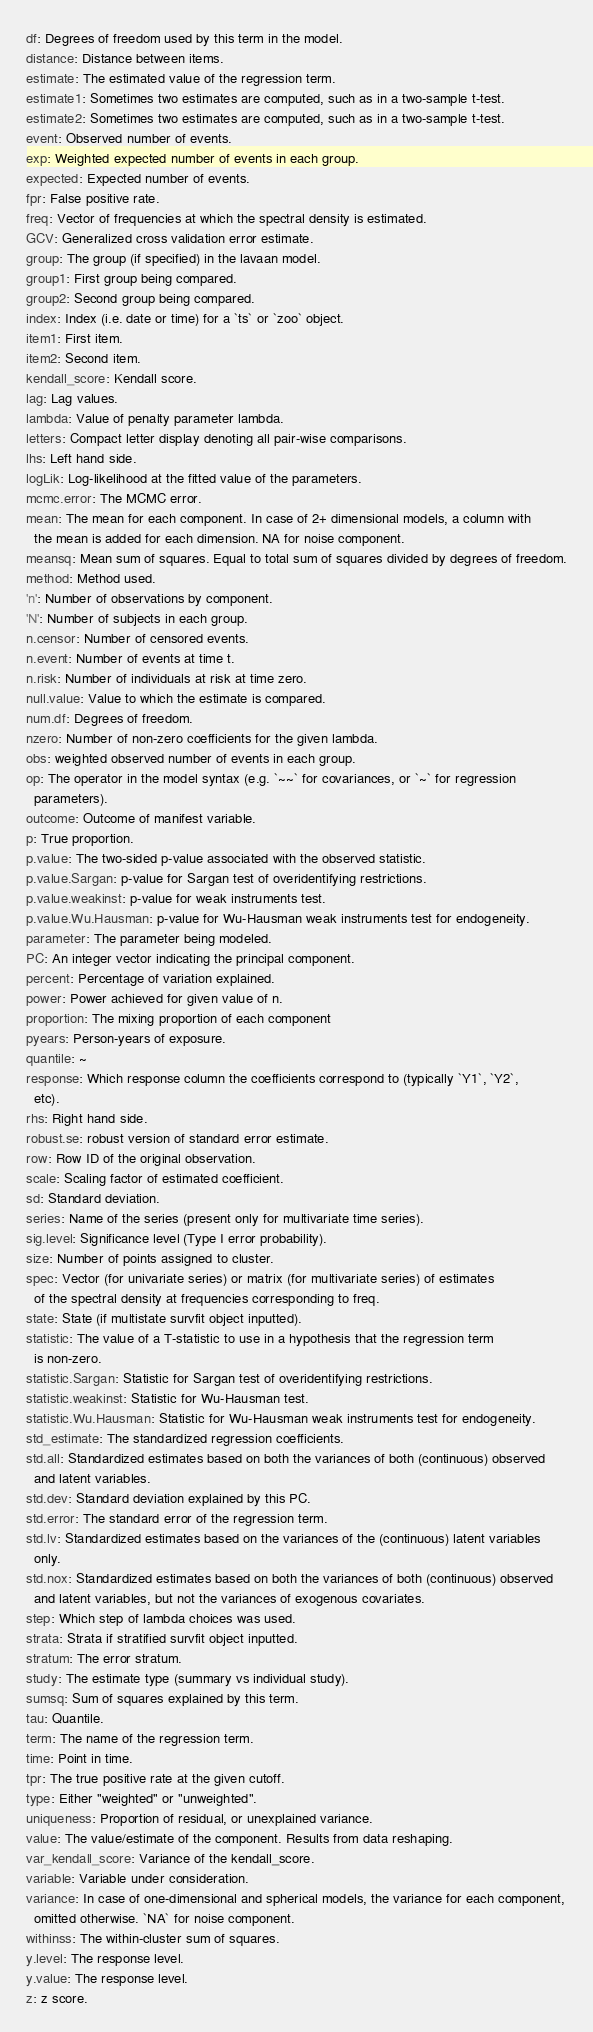Convert code to text. <code><loc_0><loc_0><loc_500><loc_500><_YAML_>df: Degrees of freedom used by this term in the model.
distance: Distance between items.
estimate: The estimated value of the regression term.
estimate1: Sometimes two estimates are computed, such as in a two-sample t-test.
estimate2: Sometimes two estimates are computed, such as in a two-sample t-test.
event: Observed number of events.
exp: Weighted expected number of events in each group.
expected: Expected number of events.
fpr: False positive rate.
freq: Vector of frequencies at which the spectral density is estimated.
GCV: Generalized cross validation error estimate.
group: The group (if specified) in the lavaan model.
group1: First group being compared.
group2: Second group being compared.
index: Index (i.e. date or time) for a `ts` or `zoo` object.
item1: First item.
item2: Second item.
kendall_score: Kendall score.
lag: Lag values.
lambda: Value of penalty parameter lambda.
letters: Compact letter display denoting all pair-wise comparisons.
lhs: Left hand side.
logLik: Log-likelihood at the fitted value of the parameters.
mcmc.error: The MCMC error.
mean: The mean for each component. In case of 2+ dimensional models, a column with
  the mean is added for each dimension. NA for noise component.
meansq: Mean sum of squares. Equal to total sum of squares divided by degrees of freedom.
method: Method used.
'n': Number of observations by component.
'N': Number of subjects in each group.
n.censor: Number of censored events.
n.event: Number of events at time t.
n.risk: Number of individuals at risk at time zero.
null.value: Value to which the estimate is compared.
num.df: Degrees of freedom.
nzero: Number of non-zero coefficients for the given lambda.
obs: weighted observed number of events in each group.
op: The operator in the model syntax (e.g. `~~` for covariances, or `~` for regression
  parameters).
outcome: Outcome of manifest variable.
p: True proportion.
p.value: The two-sided p-value associated with the observed statistic.
p.value.Sargan: p-value for Sargan test of overidentifying restrictions.
p.value.weakinst: p-value for weak instruments test.
p.value.Wu.Hausman: p-value for Wu-Hausman weak instruments test for endogeneity.
parameter: The parameter being modeled.
PC: An integer vector indicating the principal component.
percent: Percentage of variation explained.
power: Power achieved for given value of n.
proportion: The mixing proportion of each component
pyears: Person-years of exposure.
quantile: ~
response: Which response column the coefficients correspond to (typically `Y1`, `Y2`,
  etc).
rhs: Right hand side.
robust.se: robust version of standard error estimate.
row: Row ID of the original observation.
scale: Scaling factor of estimated coefficient.
sd: Standard deviation.
series: Name of the series (present only for multivariate time series).
sig.level: Significance level (Type I error probability).
size: Number of points assigned to cluster.
spec: Vector (for univariate series) or matrix (for multivariate series) of estimates
  of the spectral density at frequencies corresponding to freq.
state: State (if multistate survfit object inputted).
statistic: The value of a T-statistic to use in a hypothesis that the regression term
  is non-zero.
statistic.Sargan: Statistic for Sargan test of overidentifying restrictions.
statistic.weakinst: Statistic for Wu-Hausman test.
statistic.Wu.Hausman: Statistic for Wu-Hausman weak instruments test for endogeneity.
std_estimate: The standardized regression coefficients.
std.all: Standardized estimates based on both the variances of both (continuous) observed
  and latent variables.
std.dev: Standard deviation explained by this PC.
std.error: The standard error of the regression term.
std.lv: Standardized estimates based on the variances of the (continuous) latent variables
  only.
std.nox: Standardized estimates based on both the variances of both (continuous) observed
  and latent variables, but not the variances of exogenous covariates.
step: Which step of lambda choices was used.
strata: Strata if stratified survfit object inputted.
stratum: The error stratum.
study: The estimate type (summary vs individual study).
sumsq: Sum of squares explained by this term.
tau: Quantile.
term: The name of the regression term.
time: Point in time.
tpr: The true positive rate at the given cutoff.
type: Either "weighted" or "unweighted".
uniqueness: Proportion of residual, or unexplained variance.
value: The value/estimate of the component. Results from data reshaping.
var_kendall_score: Variance of the kendall_score.
variable: Variable under consideration.
variance: In case of one-dimensional and spherical models, the variance for each component,
  omitted otherwise. `NA` for noise component.
withinss: The within-cluster sum of squares.
y.level: The response level.
y.value: The response level.
z: z score.
</code> 